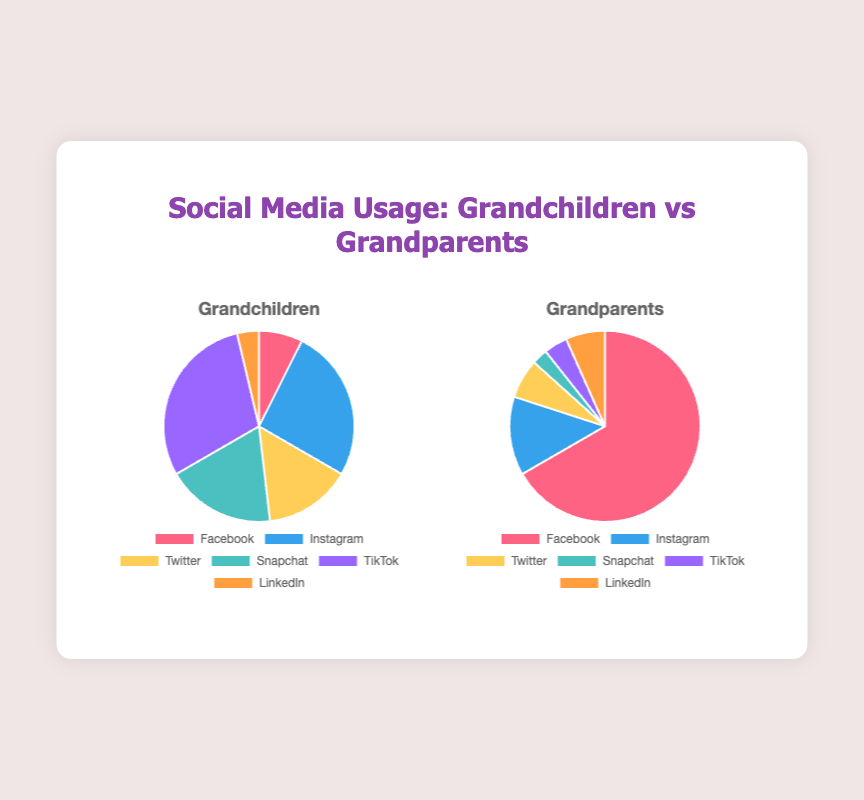Which social media platform do Grandchildren use the most? The chart for Grandchildren shows the largest slice of the pie is associated with TikTok, which visually indicates it is the most used platform.
Answer: TikTok Which social media platform do Grandparents use the most? The chart for Grandparents shows the largest slice of the pie is associated with Facebook, which visually indicates it is the most used platform.
Answer: Facebook What is the total percentage usage of Instagram and Twitter among Grandparents? First, identify the percentage for Instagram (10%) and Twitter (5%). Add them together (10% + 5% = 15%).
Answer: 15% How does the usage of LinkedIn compare between Grandchildren and Grandparents? Both charts show LinkedIn with equal-sized slices, indicating usage values of 5 each.
Answer: Equal Which social media platform has the least usage among Grandchildren? The smallest slice in the Grandchildren's chart is for LinkedIn, indicating it is the least used platform.
Answer: LinkedIn Which group uses Facebook more, Grandchildren or Grandparents? The Grandparents' chart has a significantly larger slice for Facebook compared to the Grandchildren's chart, meaning Grandparents use Facebook more.
Answer: Grandparents What is the sum of percentage uses for Snapchat and TikTok among Grandchildren? First, identify the percentage for Snapchat (25%) and TikTok (40%). Add them together (25% + 40% = 65%).
Answer: 65% Compare the usage of Snapchat and Instagram among Grandparents. The Grandparents’ chart shows two slices for Snapchat (2%) and Instagram (10%). Thus, Instagram is used more than Snapchat among Grandparents.
Answer: Instagram more than Snapchat What is the difference in usage of Twitter between Grandchildren and Grandparents? First, identify the percentage for Twitter from both charts: Grandchildren (20%) and Grandparents (5%). The difference is calculated as 20% - 5% = 15%.
Answer: 15% Which social media platform has the most significant difference in usage between the two groups? The most significant difference is seen with Facebook, where Grandparents have 50% usage compared to the Grandchildren's 10%, a difference of 40%.
Answer: Facebook 